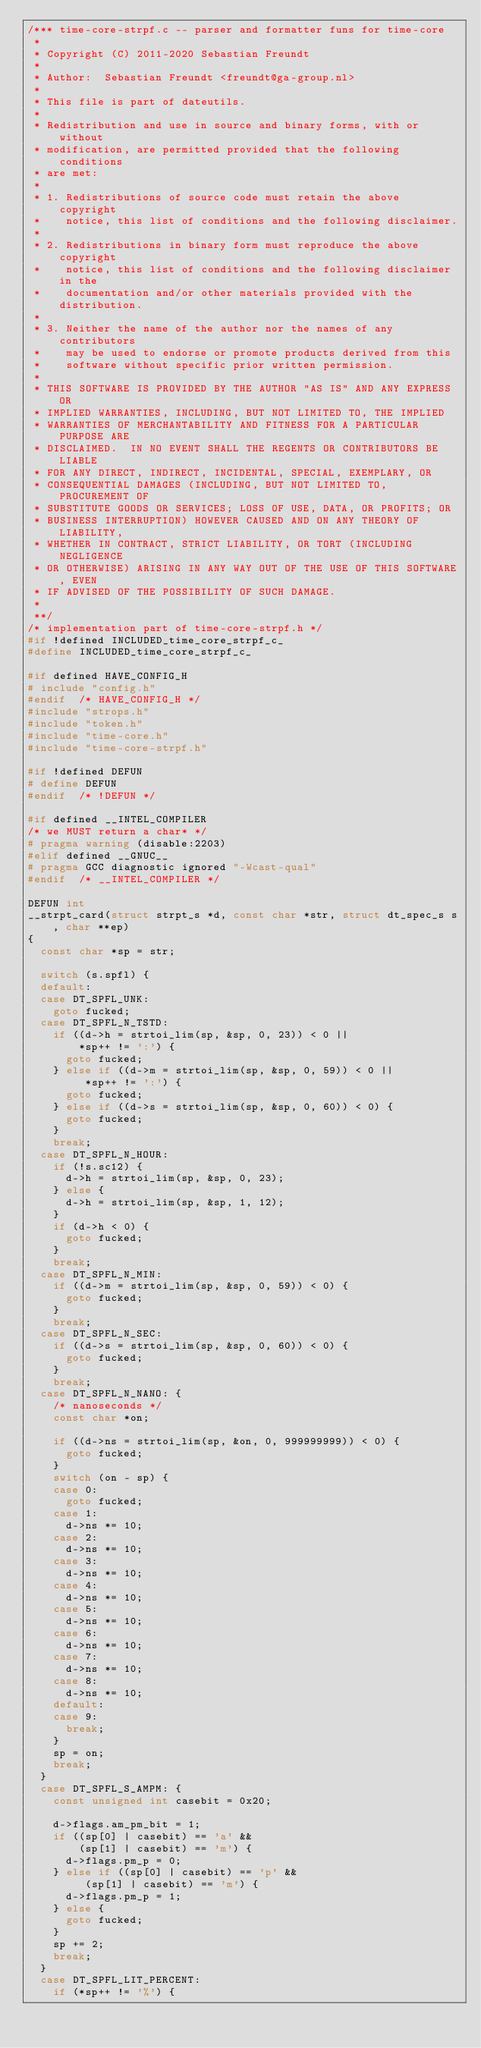Convert code to text. <code><loc_0><loc_0><loc_500><loc_500><_C_>/*** time-core-strpf.c -- parser and formatter funs for time-core
 *
 * Copyright (C) 2011-2020 Sebastian Freundt
 *
 * Author:  Sebastian Freundt <freundt@ga-group.nl>
 *
 * This file is part of dateutils.
 *
 * Redistribution and use in source and binary forms, with or without
 * modification, are permitted provided that the following conditions
 * are met:
 *
 * 1. Redistributions of source code must retain the above copyright
 *    notice, this list of conditions and the following disclaimer.
 *
 * 2. Redistributions in binary form must reproduce the above copyright
 *    notice, this list of conditions and the following disclaimer in the
 *    documentation and/or other materials provided with the distribution.
 *
 * 3. Neither the name of the author nor the names of any contributors
 *    may be used to endorse or promote products derived from this
 *    software without specific prior written permission.
 *
 * THIS SOFTWARE IS PROVIDED BY THE AUTHOR "AS IS" AND ANY EXPRESS OR
 * IMPLIED WARRANTIES, INCLUDING, BUT NOT LIMITED TO, THE IMPLIED
 * WARRANTIES OF MERCHANTABILITY AND FITNESS FOR A PARTICULAR PURPOSE ARE
 * DISCLAIMED.  IN NO EVENT SHALL THE REGENTS OR CONTRIBUTORS BE LIABLE
 * FOR ANY DIRECT, INDIRECT, INCIDENTAL, SPECIAL, EXEMPLARY, OR
 * CONSEQUENTIAL DAMAGES (INCLUDING, BUT NOT LIMITED TO, PROCUREMENT OF
 * SUBSTITUTE GOODS OR SERVICES; LOSS OF USE, DATA, OR PROFITS; OR
 * BUSINESS INTERRUPTION) HOWEVER CAUSED AND ON ANY THEORY OF LIABILITY,
 * WHETHER IN CONTRACT, STRICT LIABILITY, OR TORT (INCLUDING NEGLIGENCE
 * OR OTHERWISE) ARISING IN ANY WAY OUT OF THE USE OF THIS SOFTWARE, EVEN
 * IF ADVISED OF THE POSSIBILITY OF SUCH DAMAGE.
 *
 **/
/* implementation part of time-core-strpf.h */
#if !defined INCLUDED_time_core_strpf_c_
#define INCLUDED_time_core_strpf_c_

#if defined HAVE_CONFIG_H
# include "config.h"
#endif	/* HAVE_CONFIG_H */
#include "strops.h"
#include "token.h"
#include "time-core.h"
#include "time-core-strpf.h"

#if !defined DEFUN
# define DEFUN
#endif	/* !DEFUN */

#if defined __INTEL_COMPILER
/* we MUST return a char* */
# pragma warning (disable:2203)
#elif defined __GNUC__
# pragma GCC diagnostic ignored "-Wcast-qual"
#endif	/* __INTEL_COMPILER */

DEFUN int
__strpt_card(struct strpt_s *d, const char *str, struct dt_spec_s s, char **ep)
{
	const char *sp = str;

	switch (s.spfl) {
	default:
	case DT_SPFL_UNK:
		goto fucked;
	case DT_SPFL_N_TSTD:
		if ((d->h = strtoi_lim(sp, &sp, 0, 23)) < 0 ||
		    *sp++ != ':') {
			goto fucked;
		} else if ((d->m = strtoi_lim(sp, &sp, 0, 59)) < 0 ||
			   *sp++ != ':') {
			goto fucked;
		} else if ((d->s = strtoi_lim(sp, &sp, 0, 60)) < 0) {
			goto fucked;
		}
		break;
	case DT_SPFL_N_HOUR:
		if (!s.sc12) {
			d->h = strtoi_lim(sp, &sp, 0, 23);
		} else {
			d->h = strtoi_lim(sp, &sp, 1, 12);
		}
		if (d->h < 0) {
			goto fucked;
		}
		break;
	case DT_SPFL_N_MIN:
		if ((d->m = strtoi_lim(sp, &sp, 0, 59)) < 0) {
			goto fucked;
		}
		break;
	case DT_SPFL_N_SEC:
		if ((d->s = strtoi_lim(sp, &sp, 0, 60)) < 0) {
			goto fucked;
		}
		break;
	case DT_SPFL_N_NANO: {
		/* nanoseconds */
		const char *on;

		if ((d->ns = strtoi_lim(sp, &on, 0, 999999999)) < 0) {
			goto fucked;
		}
		switch (on - sp) {
		case 0:
			goto fucked;
		case 1:
			d->ns *= 10;
		case 2:
			d->ns *= 10;
		case 3:
			d->ns *= 10;
		case 4:
			d->ns *= 10;
		case 5:
			d->ns *= 10;
		case 6:
			d->ns *= 10;
		case 7:
			d->ns *= 10;
		case 8:
			d->ns *= 10;
		default:
		case 9:
			break;
		}
		sp = on;
		break;
	}
	case DT_SPFL_S_AMPM: {
		const unsigned int casebit = 0x20;

		d->flags.am_pm_bit = 1;
		if ((sp[0] | casebit) == 'a' &&
		    (sp[1] | casebit) == 'm') {
			d->flags.pm_p = 0;
		} else if ((sp[0] | casebit) == 'p' &&
			   (sp[1] | casebit) == 'm') {
			d->flags.pm_p = 1;
		} else {
			goto fucked;
		}
		sp += 2;
		break;
	}
	case DT_SPFL_LIT_PERCENT:
		if (*sp++ != '%') {</code> 